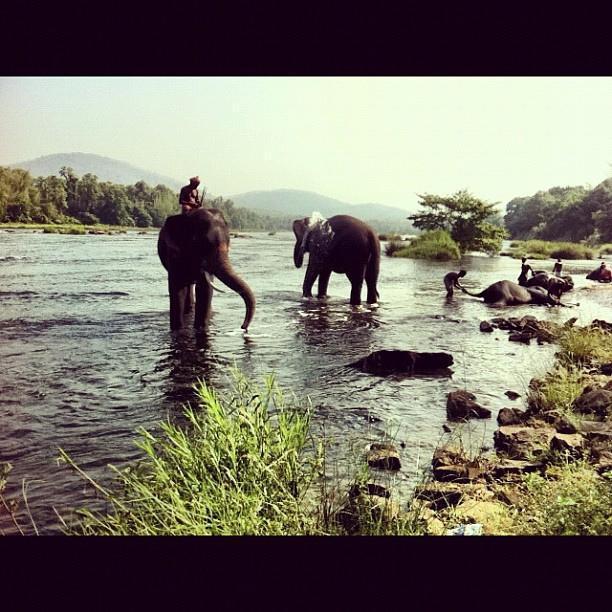How many elephants are in the picture?
Give a very brief answer. 2. How many sheep are surrounding the hay?
Give a very brief answer. 0. 